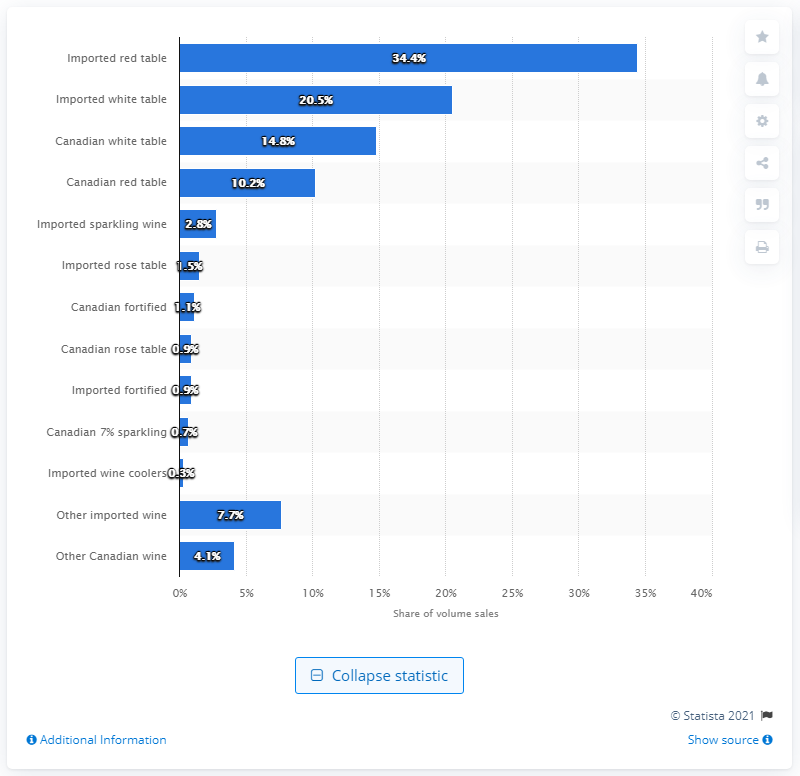Point out several critical features in this image. In 2017, 34.4% of Ontario's wine volume was imported. 